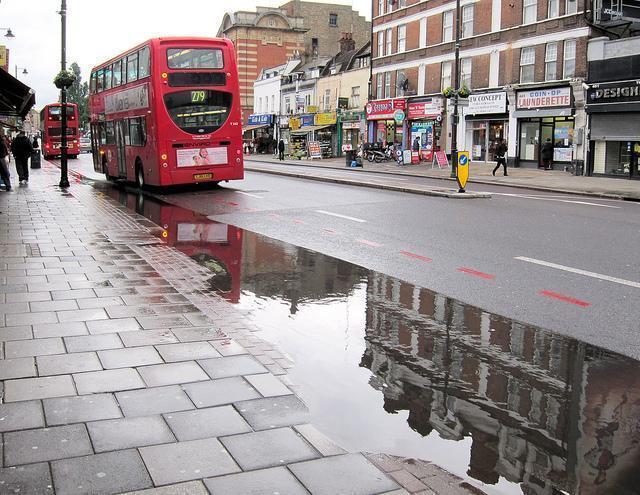If you wanted to wash clothes near here what would you need?
Choose the correct response and explain in the format: 'Answer: answer
Rationale: rationale.'
Options: Credit cards, nothing, dollar bills, coins. Answer: coins.
Rationale: There is a launderette on the street and the sign on the front of the building shows what method of payment is needed for operation. 